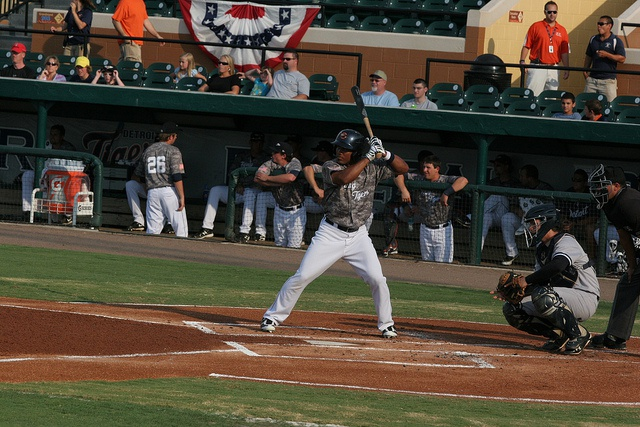Describe the objects in this image and their specific colors. I can see people in black, gray, darkgray, and maroon tones, chair in black, darkgray, gray, and maroon tones, people in black, lightgray, gray, and darkgray tones, people in black, darkgray, gray, and maroon tones, and people in black, gray, darkgray, and brown tones in this image. 